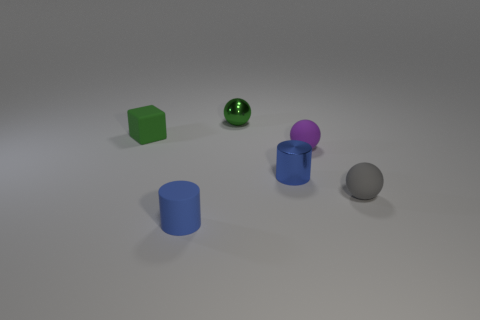What materials do the objects on the table seem to be made of? The objects presented appear to be made from various materials that suggest a diverse tactile experience. The green cube and purple sphere are reminiscent of matte, possibly plastic surfaces, while the silver sphere and cylinders - both blue and the smaller chrome one - give the impression of being metallic due to their reflective qualities. 